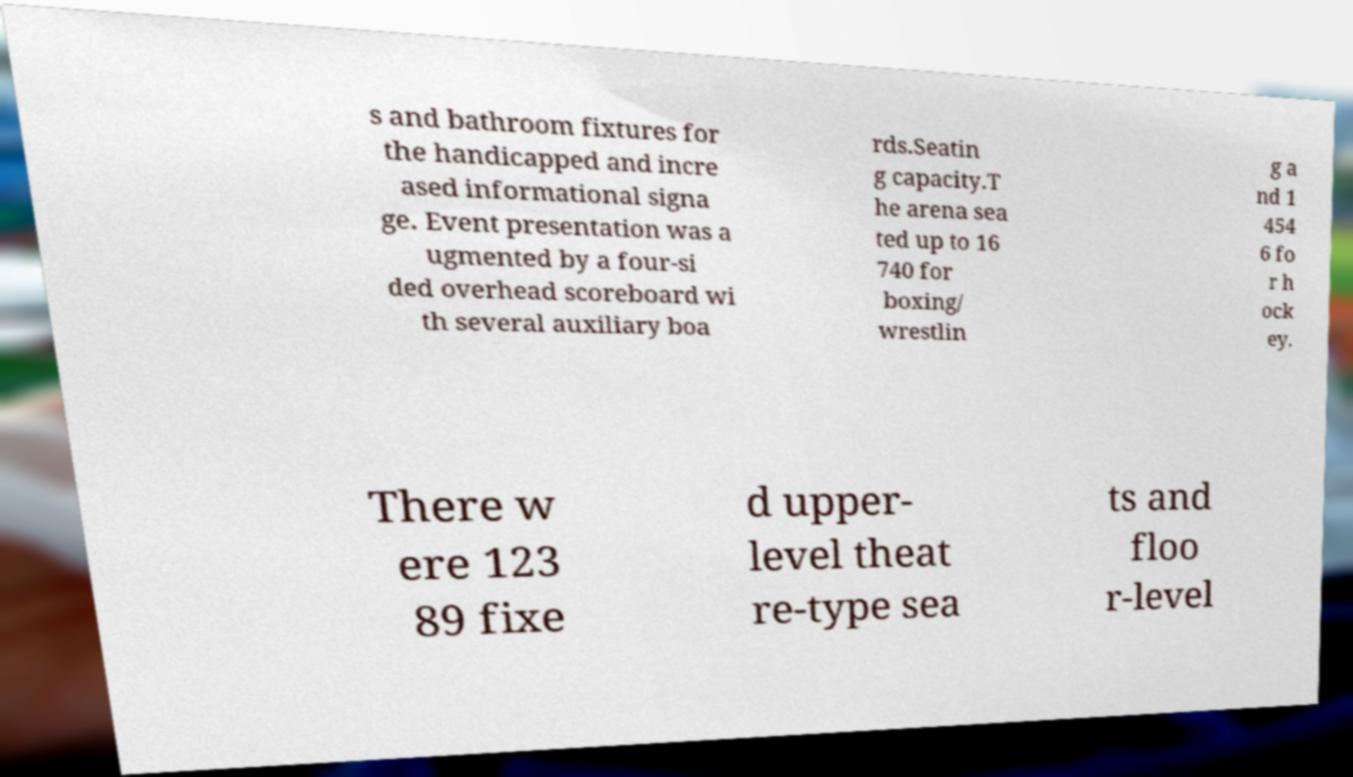Can you read and provide the text displayed in the image?This photo seems to have some interesting text. Can you extract and type it out for me? s and bathroom fixtures for the handicapped and incre ased informational signa ge. Event presentation was a ugmented by a four-si ded overhead scoreboard wi th several auxiliary boa rds.Seatin g capacity.T he arena sea ted up to 16 740 for boxing/ wrestlin g a nd 1 454 6 fo r h ock ey. There w ere 123 89 fixe d upper- level theat re-type sea ts and floo r-level 